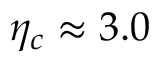<formula> <loc_0><loc_0><loc_500><loc_500>\eta _ { c } \approx 3 . 0</formula> 